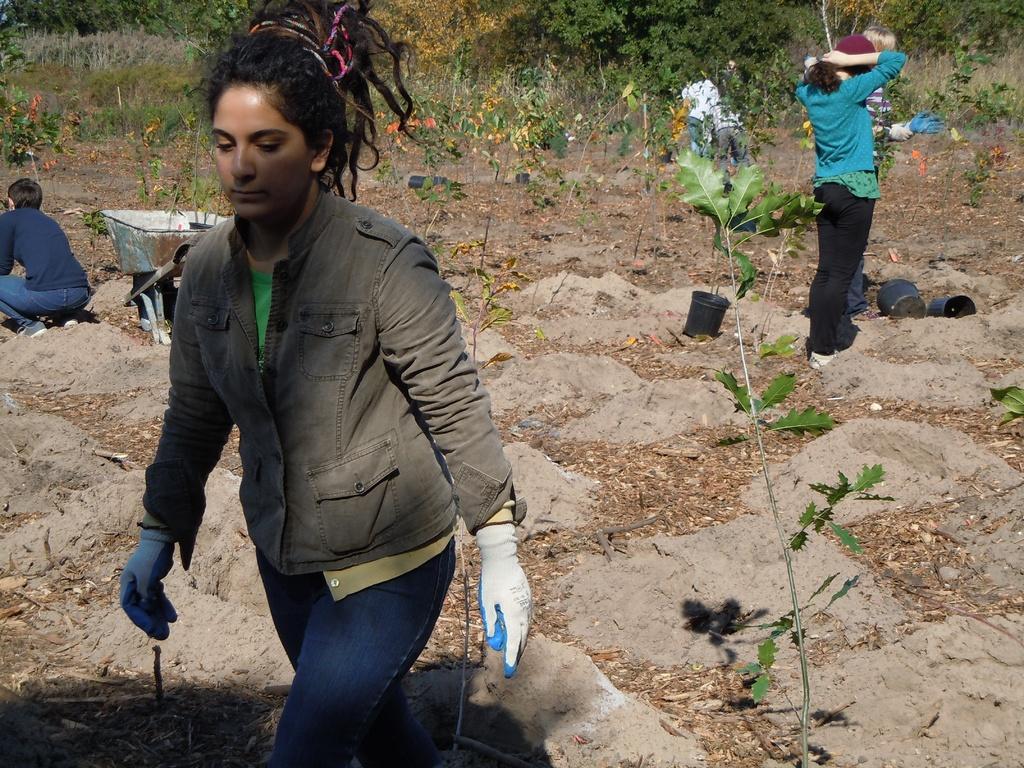Please provide a concise description of this image. In this image in the front there is woman walking and there is a plant. In the background there are persons standing, sitting and there are trees and plants. 